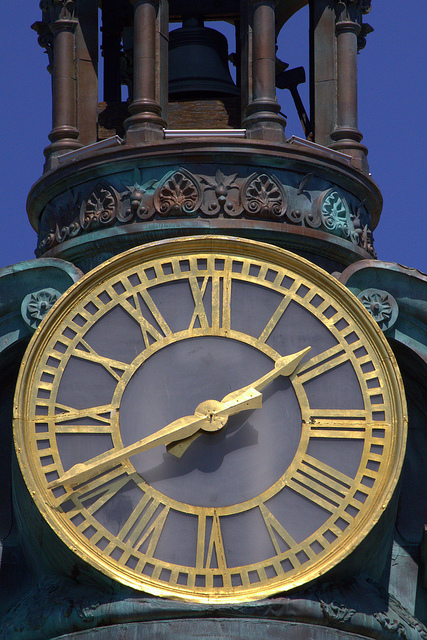Identify the text displayed in this image. XI XI V 